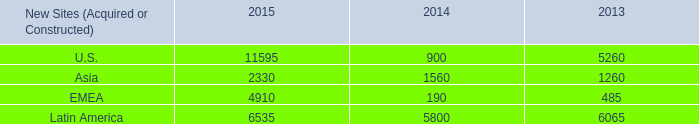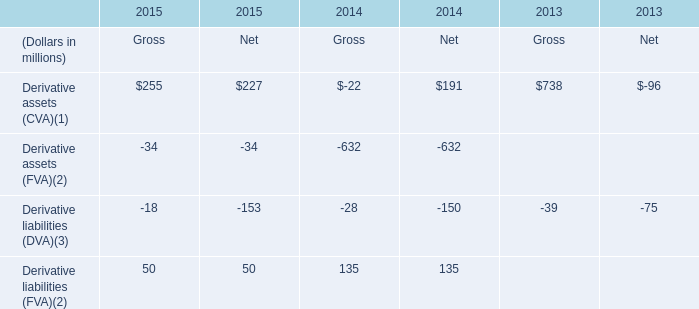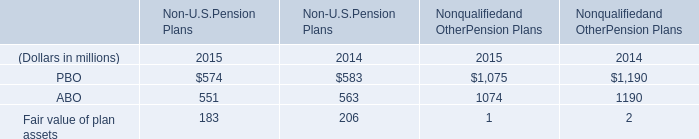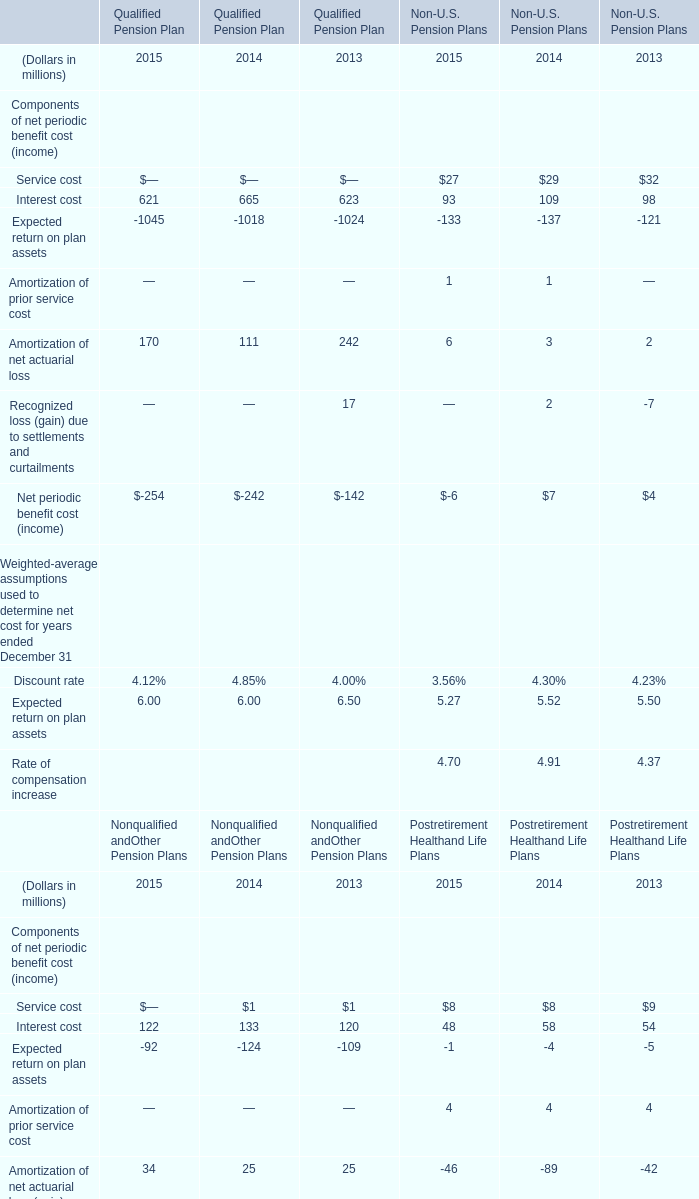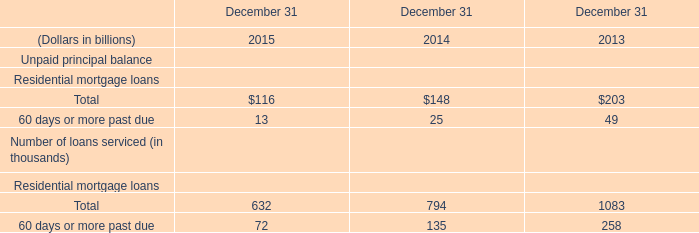What's the difference of Interest cost between 2014 and 2015? (in million) 
Computations: (122 - 133)
Answer: -11.0. 